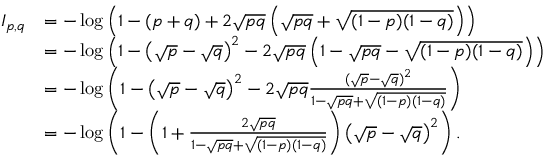<formula> <loc_0><loc_0><loc_500><loc_500>\begin{array} { r l } { I _ { p , q } } & { = - \log \left ( 1 - ( p + q ) + 2 \sqrt { p q } \left ( \sqrt { p q } + \sqrt { ( 1 - p ) ( 1 - q ) } \right ) \right ) } \\ & { = - \log \left ( 1 - \left ( \sqrt { p } - \sqrt { q } \right ) ^ { 2 } - 2 \sqrt { p q } \left ( 1 - \sqrt { p q } - \sqrt { ( 1 - p ) ( 1 - q ) } \right ) \right ) } \\ & { = - \log \left ( 1 - \left ( \sqrt { p } - \sqrt { q } \right ) ^ { 2 } - 2 \sqrt { p q } \frac { ( \sqrt { p } - \sqrt { q } ) ^ { 2 } } { 1 - \sqrt { p q } + \sqrt { ( 1 - p ) ( 1 - q ) } } \right ) } \\ & { = - \log \left ( 1 - \left ( 1 + \frac { 2 \sqrt { p q } } { 1 - \sqrt { p q } + \sqrt { ( 1 - p ) ( 1 - q ) } } \right ) \left ( \sqrt { p } - \sqrt { q } \right ) ^ { 2 } \right ) . } \end{array}</formula> 